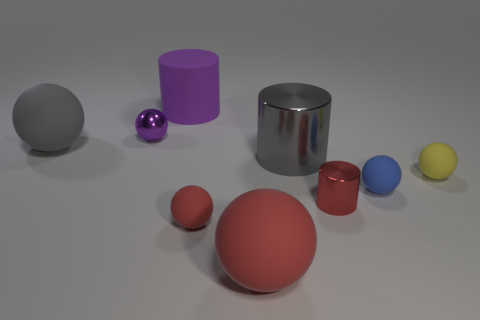Subtract all yellow balls. How many balls are left? 5 Subtract all large red spheres. How many spheres are left? 5 Subtract all blue spheres. Subtract all gray cylinders. How many spheres are left? 5 Add 1 big gray metal objects. How many objects exist? 10 Subtract all spheres. How many objects are left? 3 Subtract all brown balls. Subtract all big rubber things. How many objects are left? 6 Add 1 purple shiny objects. How many purple shiny objects are left? 2 Add 2 shiny balls. How many shiny balls exist? 3 Subtract 0 brown cubes. How many objects are left? 9 